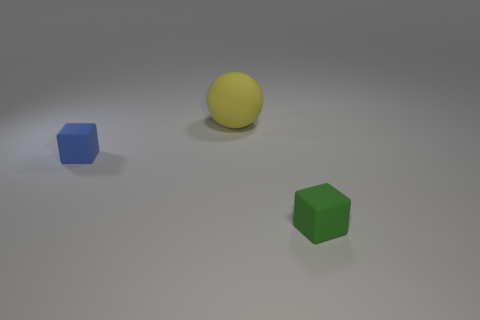Is the number of small blue things that are in front of the green matte cube less than the number of small red spheres?
Give a very brief answer. No. Is the number of tiny blue cubes on the right side of the tiny blue thing less than the number of tiny blue objects that are right of the large yellow sphere?
Offer a very short reply. No. How many blocks are small matte objects or green objects?
Provide a succinct answer. 2. Is the small thing on the left side of the tiny green rubber object made of the same material as the cube that is on the right side of the sphere?
Offer a terse response. Yes. There is a green rubber thing that is the same size as the blue cube; what is its shape?
Offer a very short reply. Cube. What number of other things are the same color as the sphere?
Provide a short and direct response. 0. What number of yellow things are spheres or small rubber objects?
Provide a succinct answer. 1. There is a small green thing in front of the yellow matte object; does it have the same shape as the small thing on the left side of the big yellow thing?
Your response must be concise. Yes. How many other things are there of the same material as the yellow thing?
Your answer should be compact. 2. There is a small cube that is behind the matte block that is in front of the blue block; is there a object to the right of it?
Your response must be concise. Yes. 